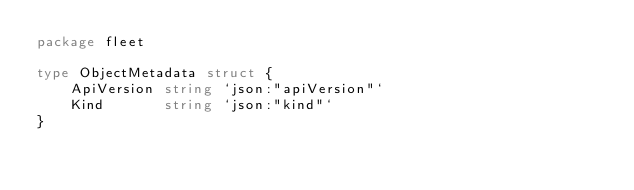Convert code to text. <code><loc_0><loc_0><loc_500><loc_500><_Go_>package fleet

type ObjectMetadata struct {
	ApiVersion string `json:"apiVersion"`
	Kind       string `json:"kind"`
}
</code> 